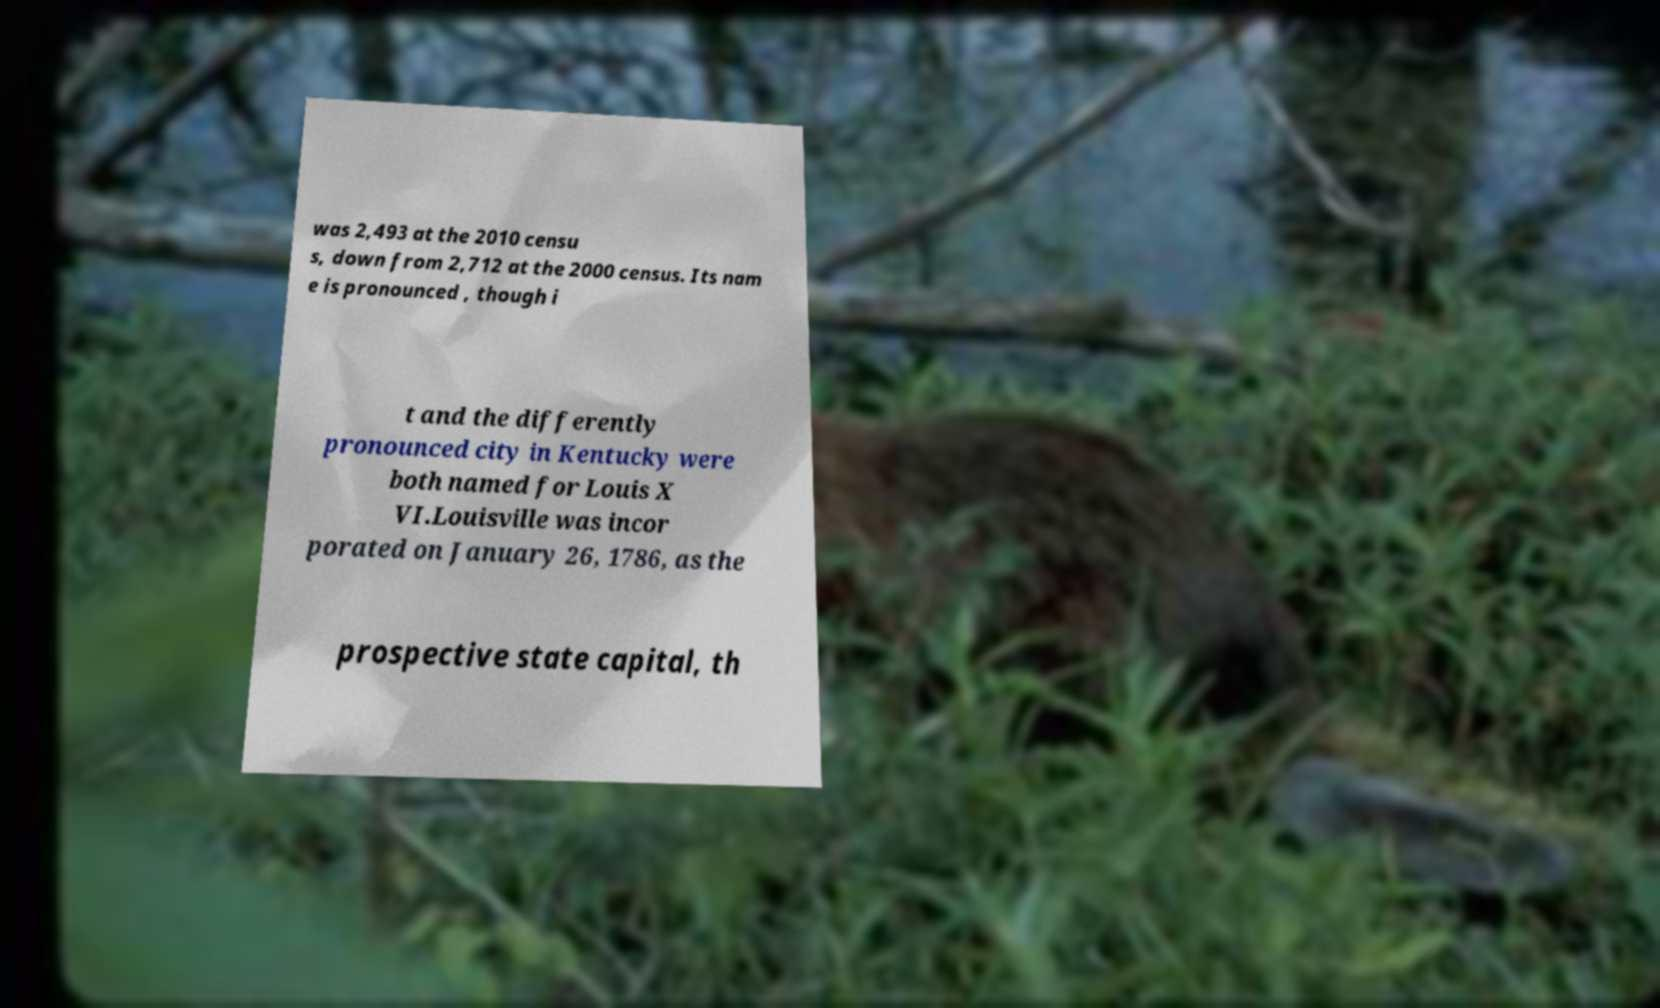For documentation purposes, I need the text within this image transcribed. Could you provide that? was 2,493 at the 2010 censu s, down from 2,712 at the 2000 census. Its nam e is pronounced , though i t and the differently pronounced city in Kentucky were both named for Louis X VI.Louisville was incor porated on January 26, 1786, as the prospective state capital, th 